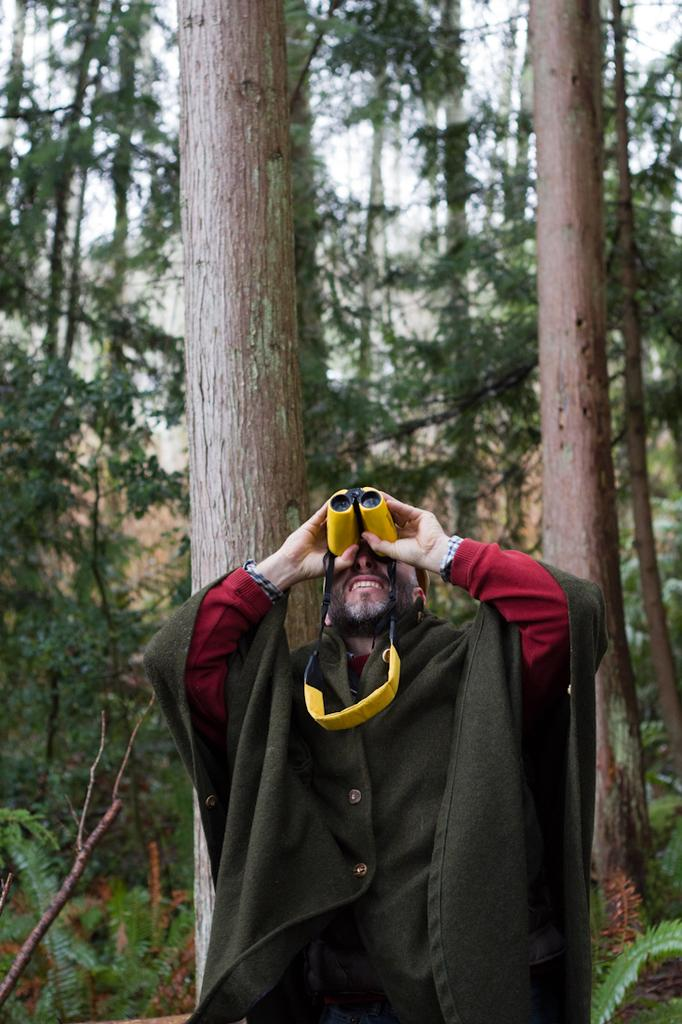What is the person in the image doing? The person is standing and looking through binoculars. What can be seen behind the person in the image? There are trees and plants behind the person. What type of iron is being used by the person in the image? There is no iron present in the image; the person is using binoculars. What part of the brain can be seen in the image? There is no brain visible in the image; it features a person looking through binoculars. 